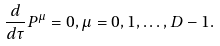Convert formula to latex. <formula><loc_0><loc_0><loc_500><loc_500>\frac { d } { d \tau } P ^ { \mu } = 0 , \mu = 0 , 1 , \dots , D - 1 .</formula> 